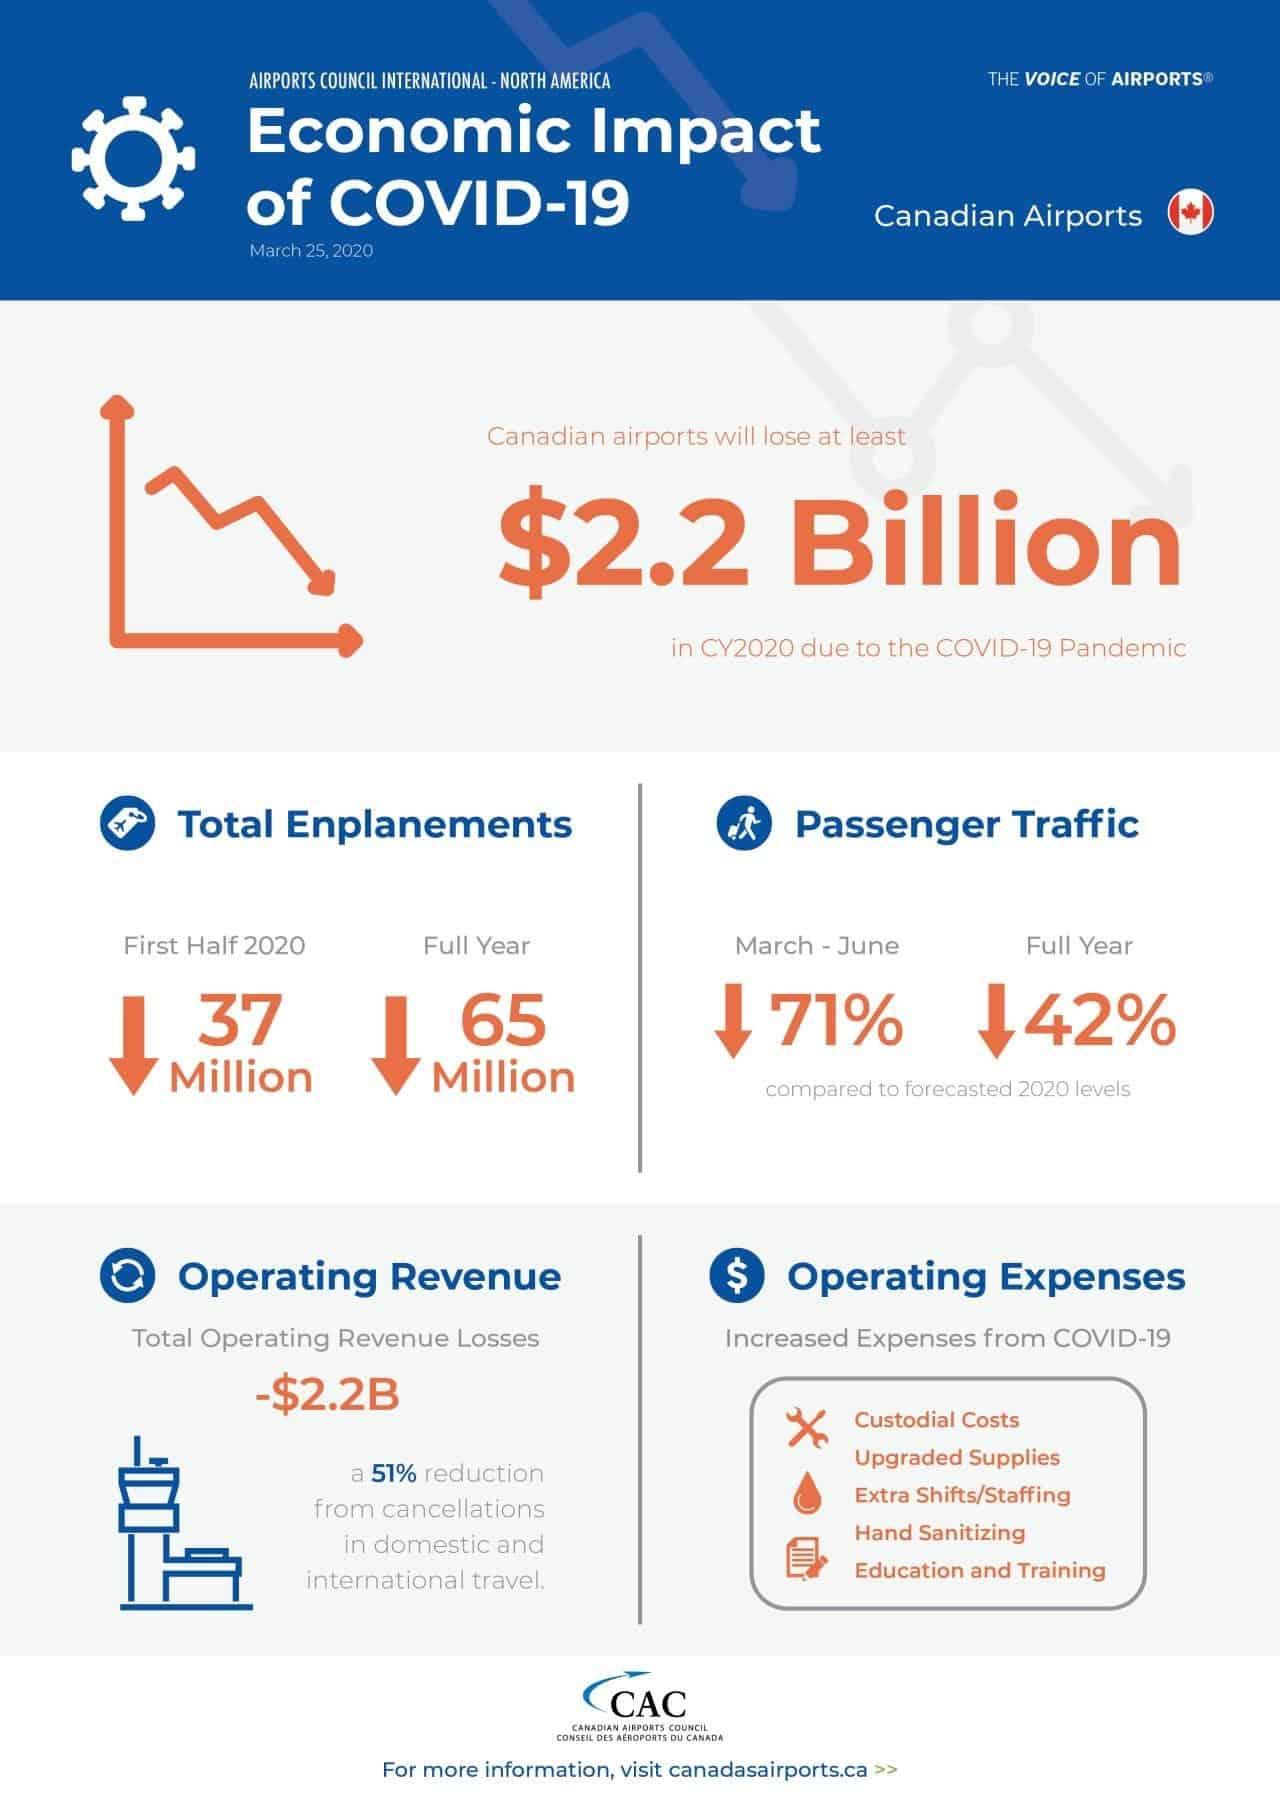Draw attention to some important aspects in this diagram. The total enplanements at Canadian airports decreased by 65 million in 2020 due to the COVID-19 pandemic. The passenger traffic at Canadian airports decreased by 42% in 2020 due to the COVID-19 pandemic. The total number of enplanements at Canadian airports decreased by 37 million in the first half of 2020 due to the COVID-19 pandemic. 